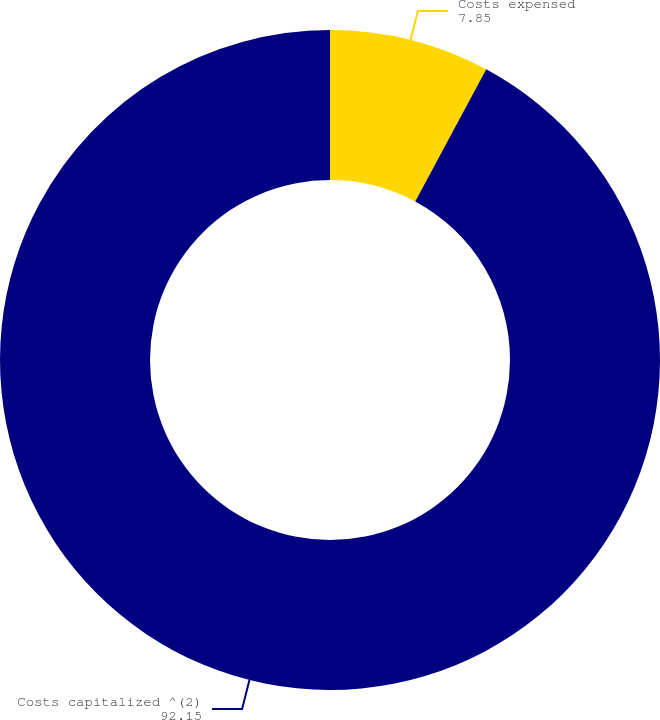Convert chart. <chart><loc_0><loc_0><loc_500><loc_500><pie_chart><fcel>Costs expensed<fcel>Costs capitalized ^(2)<nl><fcel>7.85%<fcel>92.15%<nl></chart> 